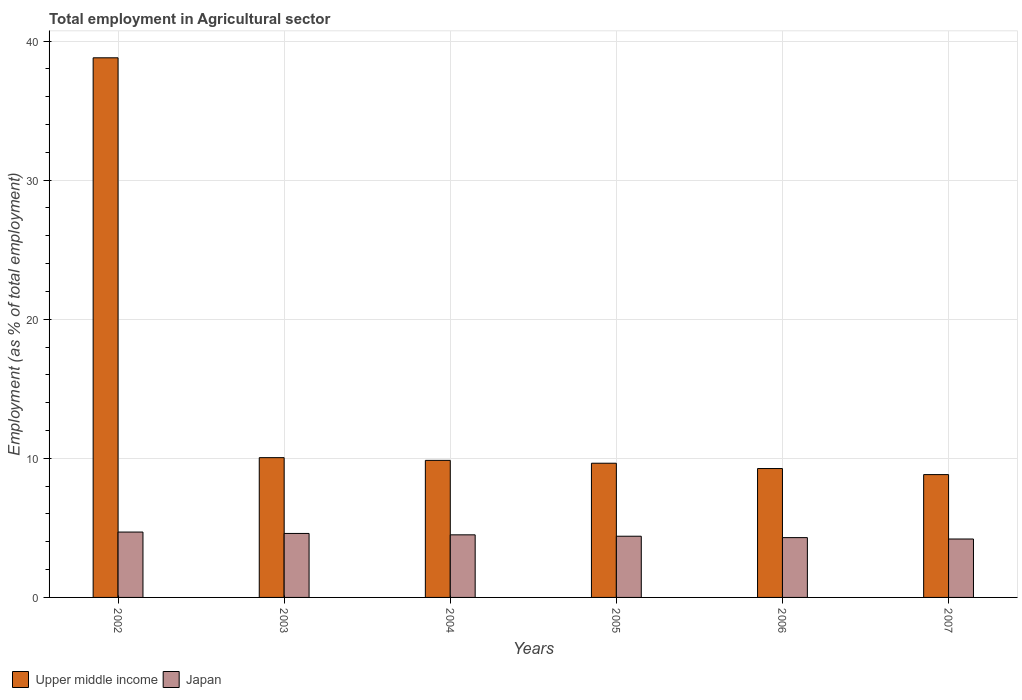How many different coloured bars are there?
Make the answer very short. 2. How many groups of bars are there?
Provide a short and direct response. 6. How many bars are there on the 2nd tick from the left?
Offer a very short reply. 2. What is the label of the 4th group of bars from the left?
Your answer should be very brief. 2005. What is the employment in agricultural sector in Upper middle income in 2006?
Your response must be concise. 9.27. Across all years, what is the maximum employment in agricultural sector in Upper middle income?
Offer a very short reply. 38.79. Across all years, what is the minimum employment in agricultural sector in Upper middle income?
Offer a very short reply. 8.83. In which year was the employment in agricultural sector in Japan maximum?
Provide a short and direct response. 2002. What is the total employment in agricultural sector in Japan in the graph?
Provide a succinct answer. 26.7. What is the difference between the employment in agricultural sector in Upper middle income in 2002 and that in 2007?
Provide a succinct answer. 29.96. What is the difference between the employment in agricultural sector in Upper middle income in 2005 and the employment in agricultural sector in Japan in 2004?
Your answer should be compact. 5.15. What is the average employment in agricultural sector in Japan per year?
Your answer should be compact. 4.45. In the year 2005, what is the difference between the employment in agricultural sector in Japan and employment in agricultural sector in Upper middle income?
Provide a succinct answer. -5.25. In how many years, is the employment in agricultural sector in Japan greater than 24 %?
Give a very brief answer. 0. What is the ratio of the employment in agricultural sector in Upper middle income in 2004 to that in 2005?
Your response must be concise. 1.02. What is the difference between the highest and the second highest employment in agricultural sector in Upper middle income?
Make the answer very short. 28.74. What is the difference between the highest and the lowest employment in agricultural sector in Japan?
Give a very brief answer. 0.5. In how many years, is the employment in agricultural sector in Japan greater than the average employment in agricultural sector in Japan taken over all years?
Keep it short and to the point. 3. What does the 1st bar from the left in 2003 represents?
Your answer should be very brief. Upper middle income. What does the 2nd bar from the right in 2002 represents?
Offer a very short reply. Upper middle income. Are all the bars in the graph horizontal?
Provide a short and direct response. No. Are the values on the major ticks of Y-axis written in scientific E-notation?
Ensure brevity in your answer.  No. Does the graph contain any zero values?
Make the answer very short. No. Where does the legend appear in the graph?
Keep it short and to the point. Bottom left. What is the title of the graph?
Keep it short and to the point. Total employment in Agricultural sector. Does "Bangladesh" appear as one of the legend labels in the graph?
Keep it short and to the point. No. What is the label or title of the Y-axis?
Provide a succinct answer. Employment (as % of total employment). What is the Employment (as % of total employment) in Upper middle income in 2002?
Keep it short and to the point. 38.79. What is the Employment (as % of total employment) in Japan in 2002?
Offer a very short reply. 4.7. What is the Employment (as % of total employment) of Upper middle income in 2003?
Your answer should be very brief. 10.05. What is the Employment (as % of total employment) of Japan in 2003?
Ensure brevity in your answer.  4.6. What is the Employment (as % of total employment) in Upper middle income in 2004?
Your answer should be compact. 9.85. What is the Employment (as % of total employment) in Japan in 2004?
Make the answer very short. 4.5. What is the Employment (as % of total employment) in Upper middle income in 2005?
Ensure brevity in your answer.  9.65. What is the Employment (as % of total employment) in Japan in 2005?
Your response must be concise. 4.4. What is the Employment (as % of total employment) in Upper middle income in 2006?
Provide a short and direct response. 9.27. What is the Employment (as % of total employment) of Japan in 2006?
Give a very brief answer. 4.3. What is the Employment (as % of total employment) of Upper middle income in 2007?
Ensure brevity in your answer.  8.83. What is the Employment (as % of total employment) of Japan in 2007?
Your answer should be compact. 4.2. Across all years, what is the maximum Employment (as % of total employment) of Upper middle income?
Offer a terse response. 38.79. Across all years, what is the maximum Employment (as % of total employment) of Japan?
Ensure brevity in your answer.  4.7. Across all years, what is the minimum Employment (as % of total employment) in Upper middle income?
Offer a terse response. 8.83. Across all years, what is the minimum Employment (as % of total employment) of Japan?
Provide a short and direct response. 4.2. What is the total Employment (as % of total employment) in Upper middle income in the graph?
Offer a terse response. 86.44. What is the total Employment (as % of total employment) in Japan in the graph?
Provide a short and direct response. 26.7. What is the difference between the Employment (as % of total employment) of Upper middle income in 2002 and that in 2003?
Make the answer very short. 28.74. What is the difference between the Employment (as % of total employment) in Japan in 2002 and that in 2003?
Provide a succinct answer. 0.1. What is the difference between the Employment (as % of total employment) of Upper middle income in 2002 and that in 2004?
Provide a short and direct response. 28.94. What is the difference between the Employment (as % of total employment) in Japan in 2002 and that in 2004?
Your answer should be compact. 0.2. What is the difference between the Employment (as % of total employment) of Upper middle income in 2002 and that in 2005?
Offer a very short reply. 29.14. What is the difference between the Employment (as % of total employment) in Upper middle income in 2002 and that in 2006?
Your answer should be compact. 29.53. What is the difference between the Employment (as % of total employment) of Japan in 2002 and that in 2006?
Offer a very short reply. 0.4. What is the difference between the Employment (as % of total employment) in Upper middle income in 2002 and that in 2007?
Provide a short and direct response. 29.96. What is the difference between the Employment (as % of total employment) in Upper middle income in 2003 and that in 2004?
Your answer should be very brief. 0.2. What is the difference between the Employment (as % of total employment) of Japan in 2003 and that in 2004?
Keep it short and to the point. 0.1. What is the difference between the Employment (as % of total employment) of Upper middle income in 2003 and that in 2005?
Offer a very short reply. 0.4. What is the difference between the Employment (as % of total employment) of Japan in 2003 and that in 2005?
Give a very brief answer. 0.2. What is the difference between the Employment (as % of total employment) in Upper middle income in 2003 and that in 2006?
Ensure brevity in your answer.  0.78. What is the difference between the Employment (as % of total employment) in Japan in 2003 and that in 2006?
Make the answer very short. 0.3. What is the difference between the Employment (as % of total employment) of Upper middle income in 2003 and that in 2007?
Your response must be concise. 1.22. What is the difference between the Employment (as % of total employment) in Upper middle income in 2004 and that in 2005?
Offer a very short reply. 0.2. What is the difference between the Employment (as % of total employment) of Japan in 2004 and that in 2005?
Ensure brevity in your answer.  0.1. What is the difference between the Employment (as % of total employment) in Upper middle income in 2004 and that in 2006?
Offer a terse response. 0.59. What is the difference between the Employment (as % of total employment) in Japan in 2004 and that in 2006?
Ensure brevity in your answer.  0.2. What is the difference between the Employment (as % of total employment) of Upper middle income in 2004 and that in 2007?
Offer a terse response. 1.02. What is the difference between the Employment (as % of total employment) of Japan in 2004 and that in 2007?
Offer a terse response. 0.3. What is the difference between the Employment (as % of total employment) in Upper middle income in 2005 and that in 2006?
Your response must be concise. 0.38. What is the difference between the Employment (as % of total employment) in Japan in 2005 and that in 2006?
Give a very brief answer. 0.1. What is the difference between the Employment (as % of total employment) in Upper middle income in 2005 and that in 2007?
Give a very brief answer. 0.82. What is the difference between the Employment (as % of total employment) of Upper middle income in 2006 and that in 2007?
Ensure brevity in your answer.  0.44. What is the difference between the Employment (as % of total employment) of Japan in 2006 and that in 2007?
Your answer should be very brief. 0.1. What is the difference between the Employment (as % of total employment) in Upper middle income in 2002 and the Employment (as % of total employment) in Japan in 2003?
Offer a very short reply. 34.19. What is the difference between the Employment (as % of total employment) of Upper middle income in 2002 and the Employment (as % of total employment) of Japan in 2004?
Ensure brevity in your answer.  34.29. What is the difference between the Employment (as % of total employment) in Upper middle income in 2002 and the Employment (as % of total employment) in Japan in 2005?
Your answer should be very brief. 34.39. What is the difference between the Employment (as % of total employment) of Upper middle income in 2002 and the Employment (as % of total employment) of Japan in 2006?
Your answer should be compact. 34.49. What is the difference between the Employment (as % of total employment) in Upper middle income in 2002 and the Employment (as % of total employment) in Japan in 2007?
Provide a succinct answer. 34.59. What is the difference between the Employment (as % of total employment) in Upper middle income in 2003 and the Employment (as % of total employment) in Japan in 2004?
Your answer should be very brief. 5.55. What is the difference between the Employment (as % of total employment) in Upper middle income in 2003 and the Employment (as % of total employment) in Japan in 2005?
Offer a very short reply. 5.65. What is the difference between the Employment (as % of total employment) of Upper middle income in 2003 and the Employment (as % of total employment) of Japan in 2006?
Provide a succinct answer. 5.75. What is the difference between the Employment (as % of total employment) in Upper middle income in 2003 and the Employment (as % of total employment) in Japan in 2007?
Keep it short and to the point. 5.85. What is the difference between the Employment (as % of total employment) of Upper middle income in 2004 and the Employment (as % of total employment) of Japan in 2005?
Ensure brevity in your answer.  5.45. What is the difference between the Employment (as % of total employment) of Upper middle income in 2004 and the Employment (as % of total employment) of Japan in 2006?
Provide a succinct answer. 5.55. What is the difference between the Employment (as % of total employment) in Upper middle income in 2004 and the Employment (as % of total employment) in Japan in 2007?
Your answer should be compact. 5.65. What is the difference between the Employment (as % of total employment) in Upper middle income in 2005 and the Employment (as % of total employment) in Japan in 2006?
Ensure brevity in your answer.  5.35. What is the difference between the Employment (as % of total employment) in Upper middle income in 2005 and the Employment (as % of total employment) in Japan in 2007?
Ensure brevity in your answer.  5.45. What is the difference between the Employment (as % of total employment) in Upper middle income in 2006 and the Employment (as % of total employment) in Japan in 2007?
Make the answer very short. 5.07. What is the average Employment (as % of total employment) in Upper middle income per year?
Provide a succinct answer. 14.41. What is the average Employment (as % of total employment) in Japan per year?
Give a very brief answer. 4.45. In the year 2002, what is the difference between the Employment (as % of total employment) of Upper middle income and Employment (as % of total employment) of Japan?
Your answer should be very brief. 34.09. In the year 2003, what is the difference between the Employment (as % of total employment) in Upper middle income and Employment (as % of total employment) in Japan?
Offer a terse response. 5.45. In the year 2004, what is the difference between the Employment (as % of total employment) of Upper middle income and Employment (as % of total employment) of Japan?
Your response must be concise. 5.35. In the year 2005, what is the difference between the Employment (as % of total employment) of Upper middle income and Employment (as % of total employment) of Japan?
Offer a very short reply. 5.25. In the year 2006, what is the difference between the Employment (as % of total employment) in Upper middle income and Employment (as % of total employment) in Japan?
Ensure brevity in your answer.  4.97. In the year 2007, what is the difference between the Employment (as % of total employment) in Upper middle income and Employment (as % of total employment) in Japan?
Give a very brief answer. 4.63. What is the ratio of the Employment (as % of total employment) of Upper middle income in 2002 to that in 2003?
Make the answer very short. 3.86. What is the ratio of the Employment (as % of total employment) of Japan in 2002 to that in 2003?
Keep it short and to the point. 1.02. What is the ratio of the Employment (as % of total employment) in Upper middle income in 2002 to that in 2004?
Provide a short and direct response. 3.94. What is the ratio of the Employment (as % of total employment) of Japan in 2002 to that in 2004?
Ensure brevity in your answer.  1.04. What is the ratio of the Employment (as % of total employment) in Upper middle income in 2002 to that in 2005?
Offer a terse response. 4.02. What is the ratio of the Employment (as % of total employment) of Japan in 2002 to that in 2005?
Provide a short and direct response. 1.07. What is the ratio of the Employment (as % of total employment) in Upper middle income in 2002 to that in 2006?
Keep it short and to the point. 4.19. What is the ratio of the Employment (as % of total employment) of Japan in 2002 to that in 2006?
Your answer should be compact. 1.09. What is the ratio of the Employment (as % of total employment) of Upper middle income in 2002 to that in 2007?
Offer a terse response. 4.39. What is the ratio of the Employment (as % of total employment) of Japan in 2002 to that in 2007?
Offer a terse response. 1.12. What is the ratio of the Employment (as % of total employment) in Upper middle income in 2003 to that in 2004?
Your answer should be compact. 1.02. What is the ratio of the Employment (as % of total employment) in Japan in 2003 to that in 2004?
Your answer should be very brief. 1.02. What is the ratio of the Employment (as % of total employment) of Upper middle income in 2003 to that in 2005?
Provide a succinct answer. 1.04. What is the ratio of the Employment (as % of total employment) of Japan in 2003 to that in 2005?
Ensure brevity in your answer.  1.05. What is the ratio of the Employment (as % of total employment) of Upper middle income in 2003 to that in 2006?
Provide a succinct answer. 1.08. What is the ratio of the Employment (as % of total employment) of Japan in 2003 to that in 2006?
Keep it short and to the point. 1.07. What is the ratio of the Employment (as % of total employment) in Upper middle income in 2003 to that in 2007?
Your answer should be compact. 1.14. What is the ratio of the Employment (as % of total employment) in Japan in 2003 to that in 2007?
Offer a very short reply. 1.1. What is the ratio of the Employment (as % of total employment) of Upper middle income in 2004 to that in 2005?
Your answer should be very brief. 1.02. What is the ratio of the Employment (as % of total employment) of Japan in 2004 to that in 2005?
Provide a succinct answer. 1.02. What is the ratio of the Employment (as % of total employment) of Upper middle income in 2004 to that in 2006?
Your answer should be very brief. 1.06. What is the ratio of the Employment (as % of total employment) in Japan in 2004 to that in 2006?
Ensure brevity in your answer.  1.05. What is the ratio of the Employment (as % of total employment) of Upper middle income in 2004 to that in 2007?
Provide a succinct answer. 1.12. What is the ratio of the Employment (as % of total employment) of Japan in 2004 to that in 2007?
Provide a short and direct response. 1.07. What is the ratio of the Employment (as % of total employment) in Upper middle income in 2005 to that in 2006?
Give a very brief answer. 1.04. What is the ratio of the Employment (as % of total employment) in Japan in 2005 to that in 2006?
Give a very brief answer. 1.02. What is the ratio of the Employment (as % of total employment) in Upper middle income in 2005 to that in 2007?
Give a very brief answer. 1.09. What is the ratio of the Employment (as % of total employment) in Japan in 2005 to that in 2007?
Your response must be concise. 1.05. What is the ratio of the Employment (as % of total employment) in Upper middle income in 2006 to that in 2007?
Provide a short and direct response. 1.05. What is the ratio of the Employment (as % of total employment) of Japan in 2006 to that in 2007?
Your answer should be very brief. 1.02. What is the difference between the highest and the second highest Employment (as % of total employment) in Upper middle income?
Keep it short and to the point. 28.74. What is the difference between the highest and the second highest Employment (as % of total employment) in Japan?
Make the answer very short. 0.1. What is the difference between the highest and the lowest Employment (as % of total employment) in Upper middle income?
Provide a short and direct response. 29.96. 